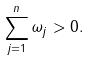Convert formula to latex. <formula><loc_0><loc_0><loc_500><loc_500>\sum _ { j = 1 } ^ { n } \omega _ { j } > 0 .</formula> 